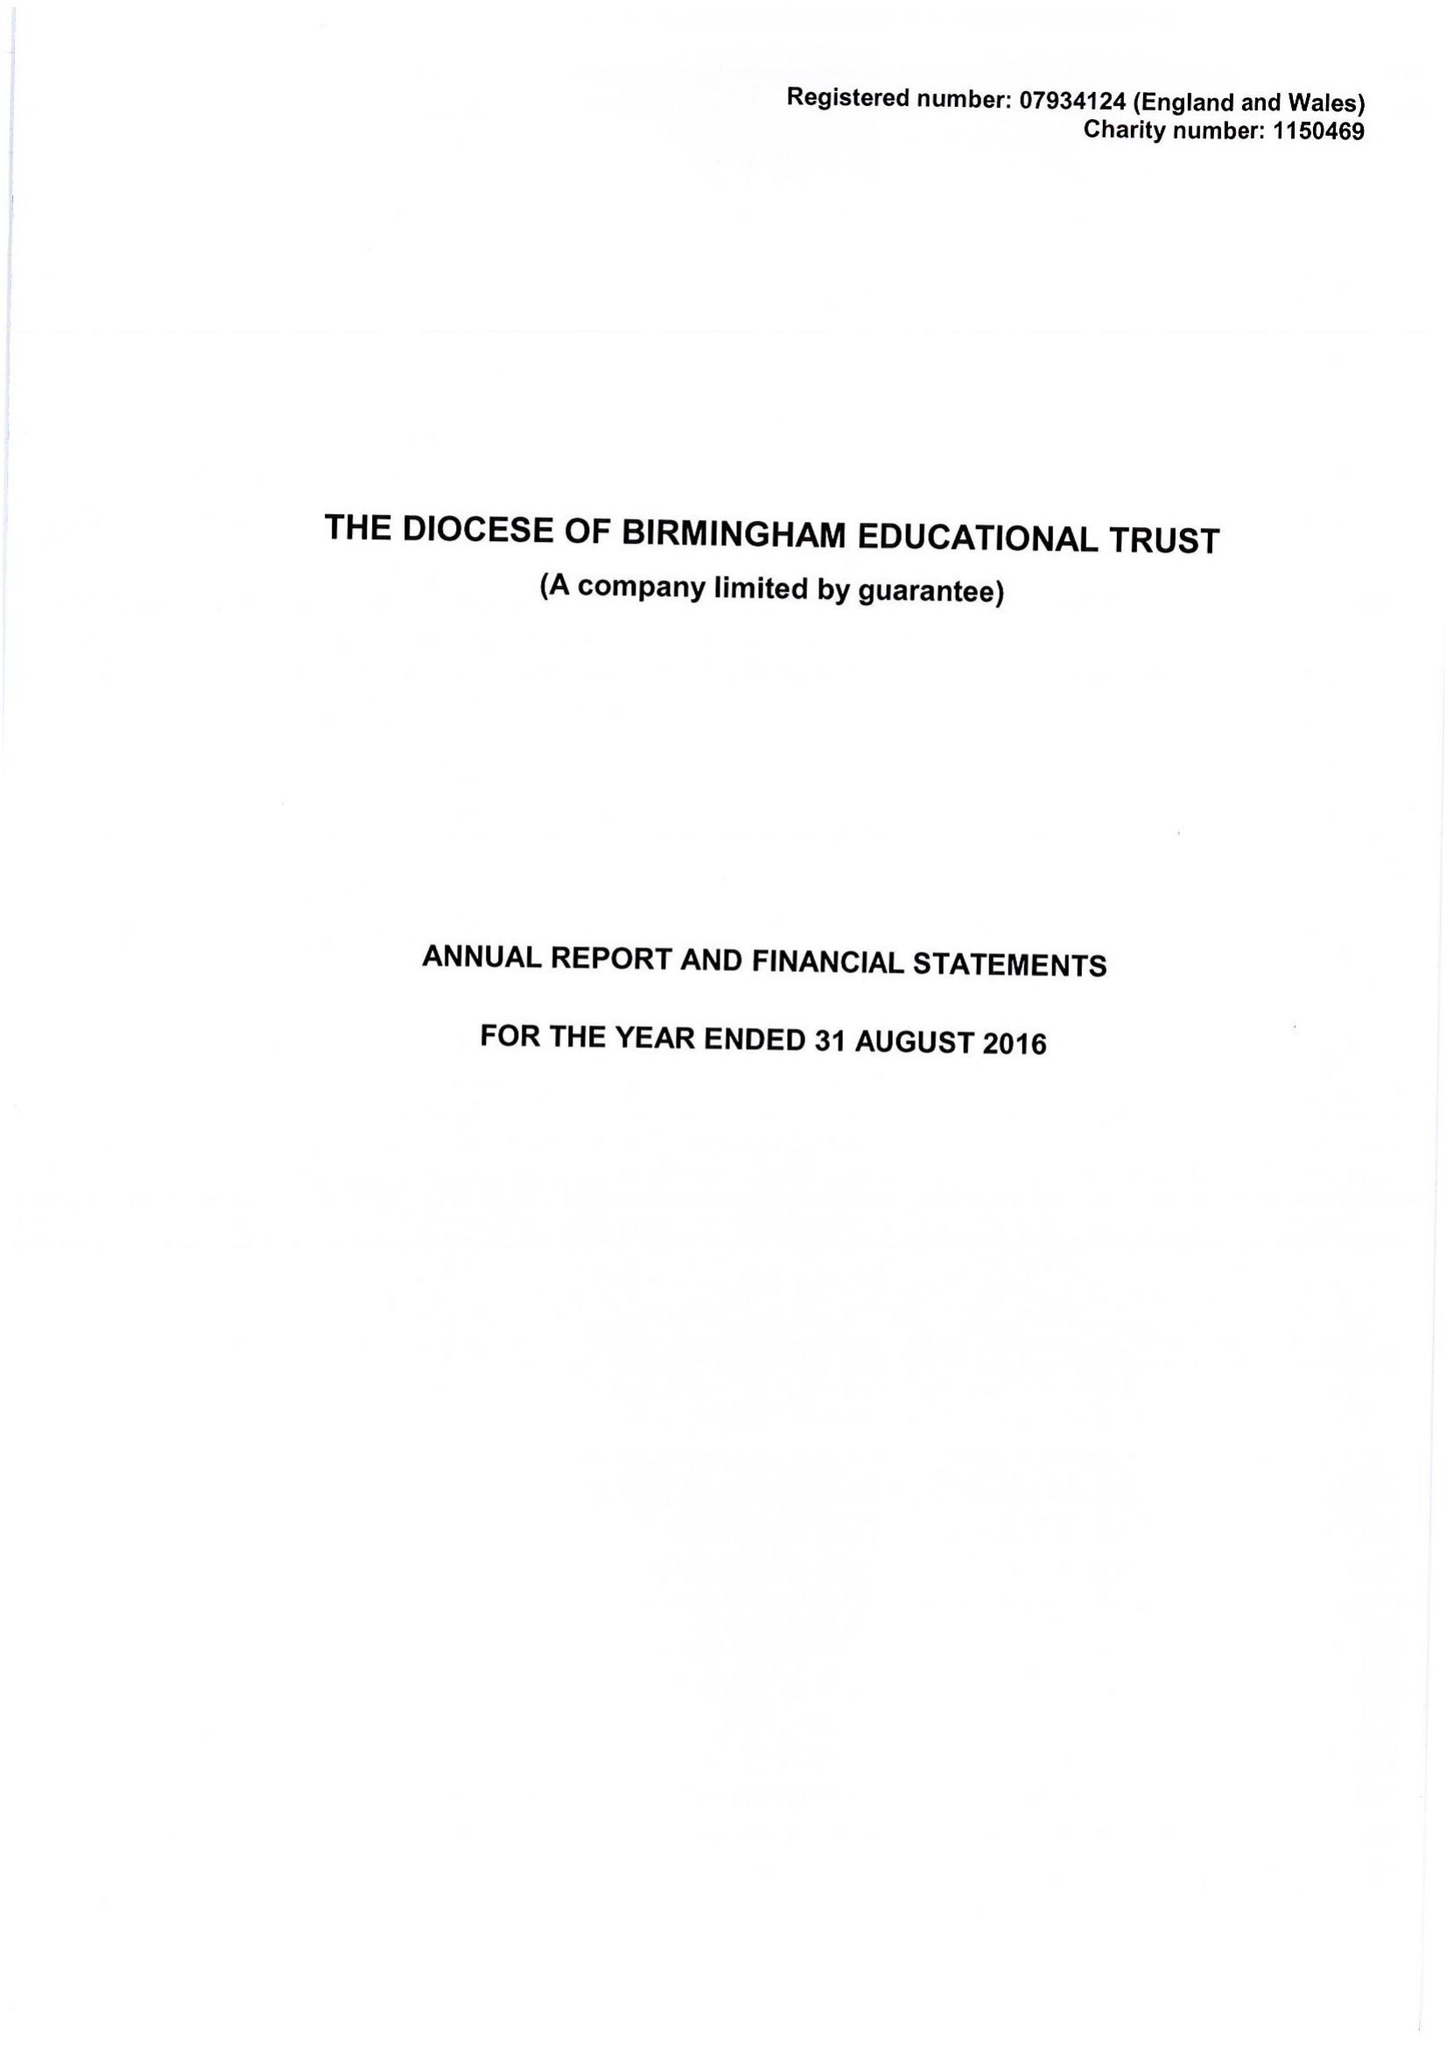What is the value for the charity_number?
Answer the question using a single word or phrase. 1150469 